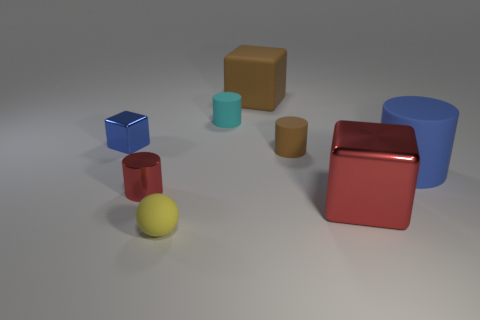Are the large brown thing and the yellow object made of the same material?
Your answer should be compact. Yes. What number of metallic objects are either large cylinders or tiny cyan spheres?
Ensure brevity in your answer.  0. The blue object left of the small yellow matte thing has what shape?
Your response must be concise. Cube. There is a yellow thing that is the same material as the blue cylinder; what size is it?
Give a very brief answer. Small. There is a rubber object that is to the left of the large brown object and behind the blue cylinder; what shape is it?
Offer a very short reply. Cylinder. There is a big rubber thing in front of the cyan thing; is its color the same as the matte cube?
Ensure brevity in your answer.  No. Does the big matte thing that is to the right of the brown cube have the same shape as the large object to the left of the big red cube?
Give a very brief answer. No. How big is the red thing on the left side of the cyan object?
Your answer should be compact. Small. There is a metal block that is behind the red shiny object on the right side of the big brown thing; what is its size?
Offer a terse response. Small. Is the number of small red shiny objects greater than the number of cylinders?
Provide a short and direct response. No. 